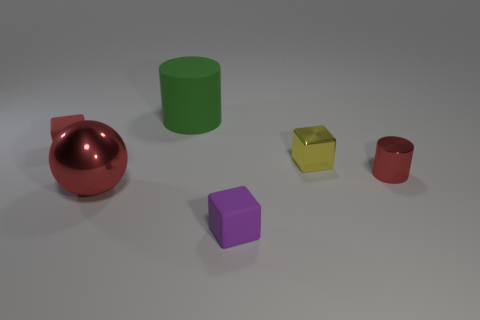Do the metallic cylinder and the big ball have the same color?
Ensure brevity in your answer.  Yes. What number of shiny things are red cylinders or red cubes?
Make the answer very short. 1. What is the size of the object that is on the right side of the green cylinder and behind the tiny red shiny thing?
Your response must be concise. Small. Are there any red balls that are behind the cylinder to the left of the purple rubber thing?
Your answer should be very brief. No. There is a large red metal object; what number of tiny objects are to the right of it?
Your answer should be compact. 3. What is the color of the metal thing that is the same shape as the tiny purple rubber thing?
Keep it short and to the point. Yellow. Are the big thing that is in front of the small red metal thing and the tiny red object to the left of the tiny metallic cube made of the same material?
Make the answer very short. No. There is a metal sphere; is it the same color as the tiny rubber block that is behind the tiny red metal cylinder?
Provide a short and direct response. Yes. The matte thing that is both in front of the big cylinder and behind the tiny shiny cylinder has what shape?
Your response must be concise. Cube. How many large green matte cylinders are there?
Give a very brief answer. 1. 